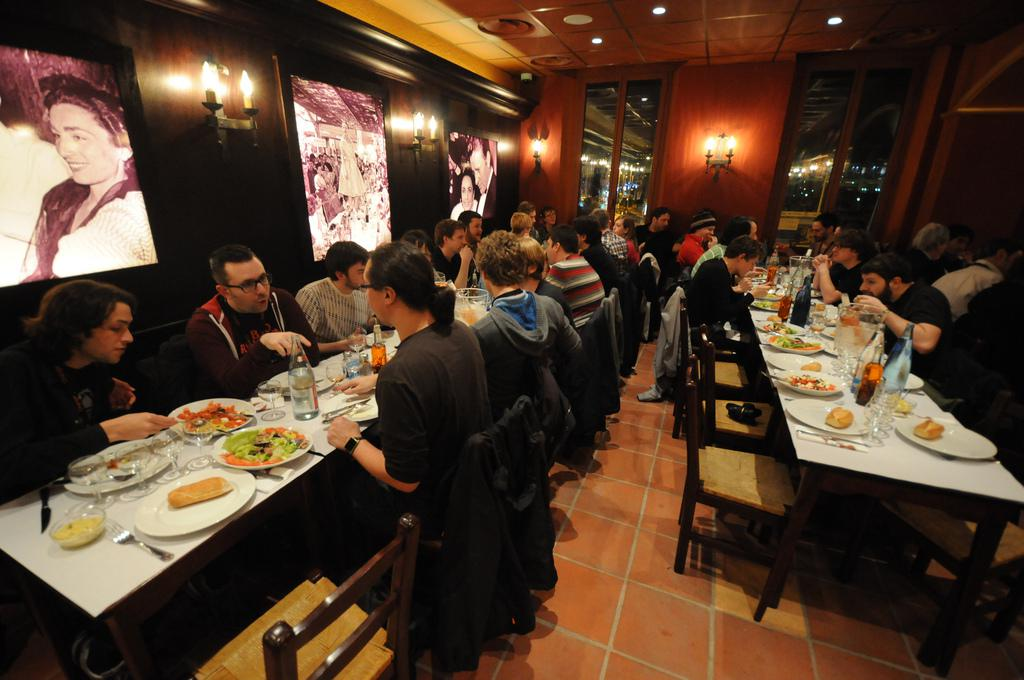Question: what are the chairs made of?
Choices:
A. Metal.
B. Aluminum.
C. Wood.
D. Concrete.
Answer with the letter. Answer: C Question: what is the atmosphere of the restaurant?
Choices:
A. Dark and cozy.
B. Light and empty.
C. Crowded.
D. Loud.
Answer with the letter. Answer: A Question: what percentage of men have beards in the image?
Choices:
A. Approximately 100 percent.
B. Approximately 10 percent.
C. Approximately 50 percent.
D. Approximately 20 percent.
Answer with the letter. Answer: B Question: why are the people seated?
Choices:
A. They are in church.
B. They are at the movies.
C. They are at the ballet.
D. They are eating.
Answer with the letter. Answer: D Question: when will the empty seat next to the guy with the pony tail, glasses and black tee shirt be filled?
Choices:
A. When the guy's wife arrives.
B. When the child returns from the bathroom.
C. When someone comes back to finish the food on the plate.
D. When someone else buys a ticket.
Answer with the letter. Answer: C Question: what is hanging on the walls?
Choices:
A. The clock.
B. Photos.
C. The calender.
D. The speakers.
Answer with the letter. Answer: B Question: what material is the floor made of?
Choices:
A. Wood.
B. Stone.
C. Ceramic.
D. Tile.
Answer with the letter. Answer: D Question: what are the people doing?
Choices:
A. Swimming.
B. Eating and socializing.
C. Taking beer.
D. Dancing.
Answer with the letter. Answer: B Question: how many rows of tables are there?
Choices:
A. Three.
B. Two.
C. Four.
D. Five.
Answer with the letter. Answer: B Question: what wrist is the man's watch on?
Choices:
A. His right.
B. His son's.
C. His wife's.
D. His left.
Answer with the letter. Answer: D Question: what color are the tiles?
Choices:
A. Terracotta.
B. Green.
C. Red.
D. Black.
Answer with the letter. Answer: A Question: what provides lighting?
Choices:
A. Wall sconces.
B. Table Lamps.
C. Reading lamps.
D. Candles.
Answer with the letter. Answer: A Question: how are the people dressed?
Choices:
A. Formal.
B. In Beachwear.
C. For a barbecue.
D. Casually.
Answer with the letter. Answer: D Question: what do the diners drape over their chairs?
Choices:
A. Their sweaters.
B. Purses.
C. Napkins.
D. Their coats.
Answer with the letter. Answer: D Question: what is this?
Choices:
A. A restaurant.
B. A grocery store.
C. A coffee shop.
D. A market.
Answer with the letter. Answer: A 